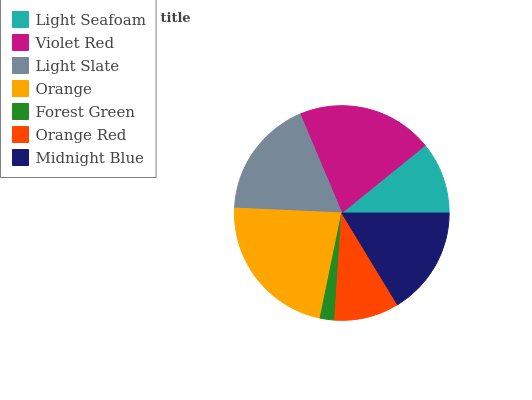Is Forest Green the minimum?
Answer yes or no. Yes. Is Orange the maximum?
Answer yes or no. Yes. Is Violet Red the minimum?
Answer yes or no. No. Is Violet Red the maximum?
Answer yes or no. No. Is Violet Red greater than Light Seafoam?
Answer yes or no. Yes. Is Light Seafoam less than Violet Red?
Answer yes or no. Yes. Is Light Seafoam greater than Violet Red?
Answer yes or no. No. Is Violet Red less than Light Seafoam?
Answer yes or no. No. Is Midnight Blue the high median?
Answer yes or no. Yes. Is Midnight Blue the low median?
Answer yes or no. Yes. Is Forest Green the high median?
Answer yes or no. No. Is Light Seafoam the low median?
Answer yes or no. No. 